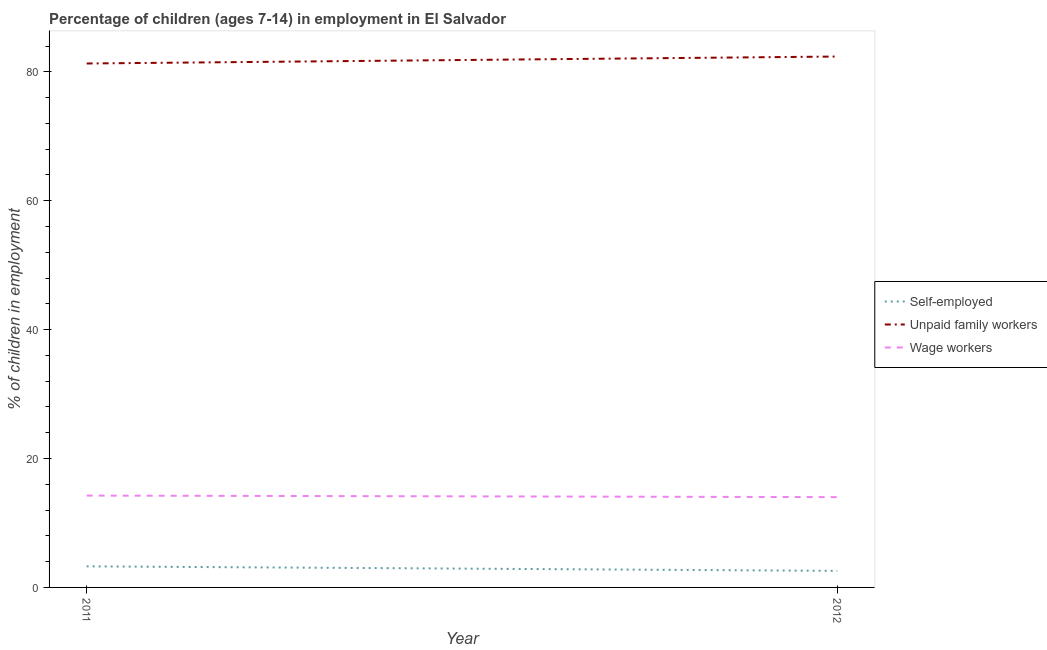How many different coloured lines are there?
Make the answer very short. 3. What is the percentage of children employed as wage workers in 2011?
Offer a terse response. 14.25. Across all years, what is the maximum percentage of children employed as unpaid family workers?
Give a very brief answer. 82.37. Across all years, what is the minimum percentage of children employed as unpaid family workers?
Offer a very short reply. 81.29. In which year was the percentage of self employed children minimum?
Provide a succinct answer. 2012. What is the total percentage of children employed as unpaid family workers in the graph?
Make the answer very short. 163.66. What is the difference between the percentage of children employed as unpaid family workers in 2011 and that in 2012?
Your answer should be very brief. -1.08. What is the difference between the percentage of children employed as wage workers in 2012 and the percentage of children employed as unpaid family workers in 2011?
Make the answer very short. -67.28. What is the average percentage of children employed as wage workers per year?
Offer a very short reply. 14.13. In the year 2012, what is the difference between the percentage of self employed children and percentage of children employed as unpaid family workers?
Offer a very short reply. -79.8. In how many years, is the percentage of self employed children greater than 68 %?
Make the answer very short. 0. What is the ratio of the percentage of self employed children in 2011 to that in 2012?
Ensure brevity in your answer.  1.27. Does the percentage of children employed as wage workers monotonically increase over the years?
Offer a very short reply. No. Is the percentage of self employed children strictly less than the percentage of children employed as unpaid family workers over the years?
Offer a terse response. Yes. How many lines are there?
Provide a short and direct response. 3. How many years are there in the graph?
Your answer should be very brief. 2. What is the difference between two consecutive major ticks on the Y-axis?
Your answer should be compact. 20. Are the values on the major ticks of Y-axis written in scientific E-notation?
Your answer should be compact. No. Does the graph contain grids?
Make the answer very short. No. Where does the legend appear in the graph?
Give a very brief answer. Center right. How many legend labels are there?
Your response must be concise. 3. How are the legend labels stacked?
Make the answer very short. Vertical. What is the title of the graph?
Provide a succinct answer. Percentage of children (ages 7-14) in employment in El Salvador. What is the label or title of the Y-axis?
Offer a terse response. % of children in employment. What is the % of children in employment in Self-employed in 2011?
Provide a short and direct response. 3.27. What is the % of children in employment of Unpaid family workers in 2011?
Your answer should be very brief. 81.29. What is the % of children in employment in Wage workers in 2011?
Offer a terse response. 14.25. What is the % of children in employment of Self-employed in 2012?
Ensure brevity in your answer.  2.57. What is the % of children in employment in Unpaid family workers in 2012?
Give a very brief answer. 82.37. What is the % of children in employment in Wage workers in 2012?
Your response must be concise. 14.01. Across all years, what is the maximum % of children in employment in Self-employed?
Make the answer very short. 3.27. Across all years, what is the maximum % of children in employment of Unpaid family workers?
Your answer should be very brief. 82.37. Across all years, what is the maximum % of children in employment of Wage workers?
Provide a short and direct response. 14.25. Across all years, what is the minimum % of children in employment in Self-employed?
Your answer should be compact. 2.57. Across all years, what is the minimum % of children in employment in Unpaid family workers?
Your response must be concise. 81.29. Across all years, what is the minimum % of children in employment in Wage workers?
Give a very brief answer. 14.01. What is the total % of children in employment of Self-employed in the graph?
Give a very brief answer. 5.84. What is the total % of children in employment in Unpaid family workers in the graph?
Your answer should be compact. 163.66. What is the total % of children in employment of Wage workers in the graph?
Ensure brevity in your answer.  28.26. What is the difference between the % of children in employment of Self-employed in 2011 and that in 2012?
Provide a succinct answer. 0.7. What is the difference between the % of children in employment of Unpaid family workers in 2011 and that in 2012?
Provide a succinct answer. -1.08. What is the difference between the % of children in employment in Wage workers in 2011 and that in 2012?
Offer a terse response. 0.24. What is the difference between the % of children in employment in Self-employed in 2011 and the % of children in employment in Unpaid family workers in 2012?
Provide a succinct answer. -79.1. What is the difference between the % of children in employment of Self-employed in 2011 and the % of children in employment of Wage workers in 2012?
Offer a very short reply. -10.74. What is the difference between the % of children in employment of Unpaid family workers in 2011 and the % of children in employment of Wage workers in 2012?
Keep it short and to the point. 67.28. What is the average % of children in employment in Self-employed per year?
Provide a short and direct response. 2.92. What is the average % of children in employment in Unpaid family workers per year?
Offer a very short reply. 81.83. What is the average % of children in employment of Wage workers per year?
Ensure brevity in your answer.  14.13. In the year 2011, what is the difference between the % of children in employment of Self-employed and % of children in employment of Unpaid family workers?
Make the answer very short. -78.02. In the year 2011, what is the difference between the % of children in employment in Self-employed and % of children in employment in Wage workers?
Provide a short and direct response. -10.98. In the year 2011, what is the difference between the % of children in employment in Unpaid family workers and % of children in employment in Wage workers?
Your response must be concise. 67.04. In the year 2012, what is the difference between the % of children in employment of Self-employed and % of children in employment of Unpaid family workers?
Ensure brevity in your answer.  -79.8. In the year 2012, what is the difference between the % of children in employment of Self-employed and % of children in employment of Wage workers?
Your answer should be compact. -11.44. In the year 2012, what is the difference between the % of children in employment of Unpaid family workers and % of children in employment of Wage workers?
Offer a terse response. 68.36. What is the ratio of the % of children in employment of Self-employed in 2011 to that in 2012?
Your answer should be very brief. 1.27. What is the ratio of the % of children in employment of Unpaid family workers in 2011 to that in 2012?
Your answer should be very brief. 0.99. What is the ratio of the % of children in employment of Wage workers in 2011 to that in 2012?
Offer a terse response. 1.02. What is the difference between the highest and the second highest % of children in employment of Unpaid family workers?
Your response must be concise. 1.08. What is the difference between the highest and the second highest % of children in employment of Wage workers?
Provide a succinct answer. 0.24. What is the difference between the highest and the lowest % of children in employment in Self-employed?
Give a very brief answer. 0.7. What is the difference between the highest and the lowest % of children in employment of Wage workers?
Offer a very short reply. 0.24. 